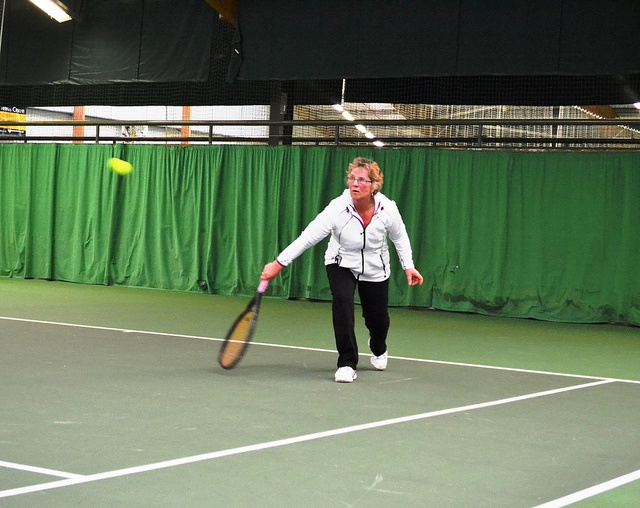Describe the objects in this image and their specific colors. I can see people in black, white, darkgray, and darkgreen tones, tennis racket in black, tan, and gray tones, and sports ball in black, yellow, lime, and lightgreen tones in this image. 